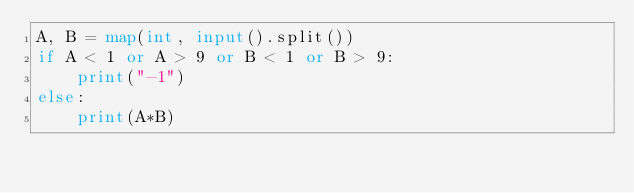<code> <loc_0><loc_0><loc_500><loc_500><_Python_>A, B = map(int, input().split())
if A < 1 or A > 9 or B < 1 or B > 9:
    print("-1")
else:
    print(A*B)</code> 